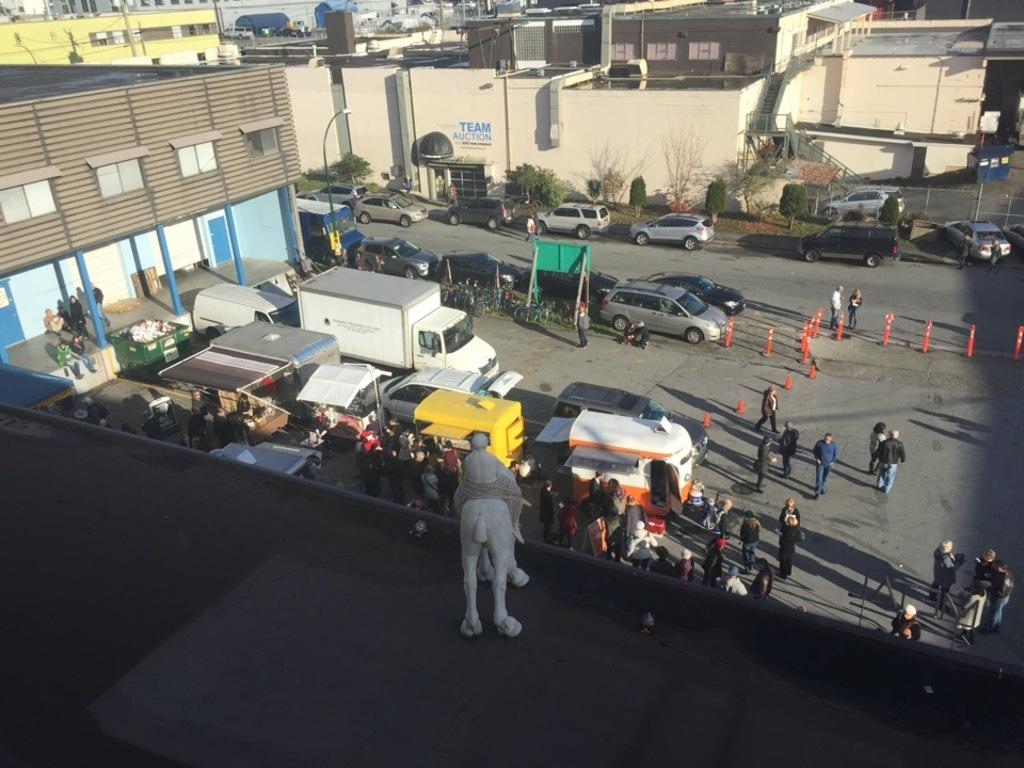Who or what can be seen in the image? There are people and vehicles in the image. What objects are present in the image that might be used for traffic control or safety? A traffic cone is present in the image. What type of natural elements can be seen in the image? There are trees in the image. What type of man-made structures are visible in the image? There are buildings in the image. What additional item can be seen in the front of the image? There is a toy in the front of the image. How many sheep are visible in the image? There are no sheep present in the image. What type of bag is being used by the people in the image? There is no bag visible in the image. 